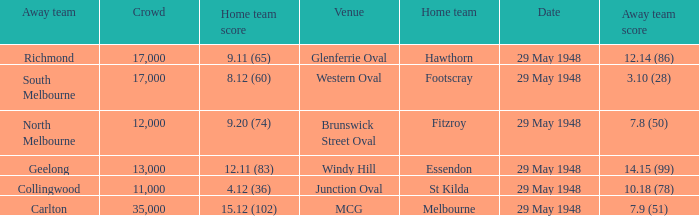In the match where footscray was the home team, how much did they score? 8.12 (60). 